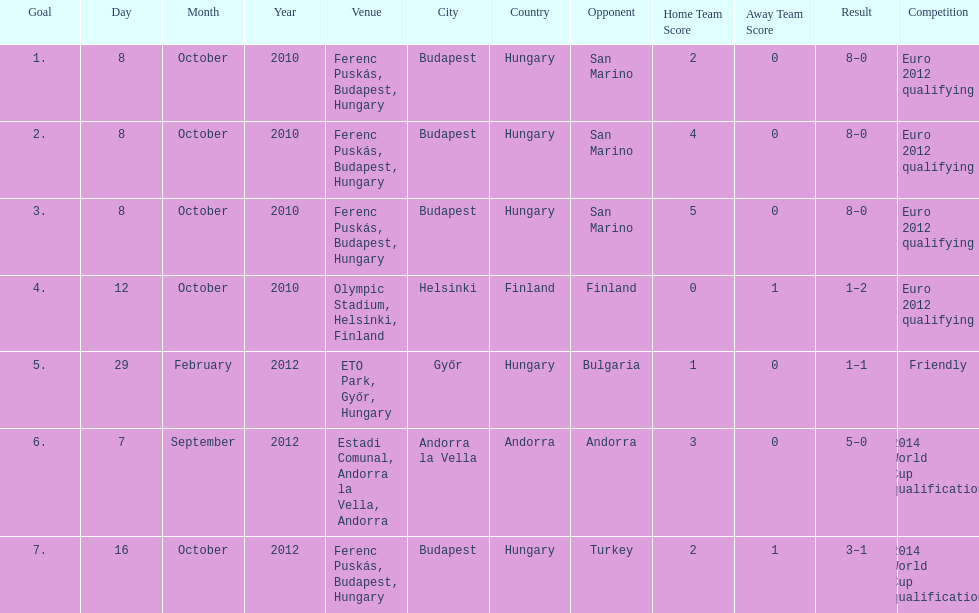What is the number of goals ádám szalai made against san marino in 2010? 3. 